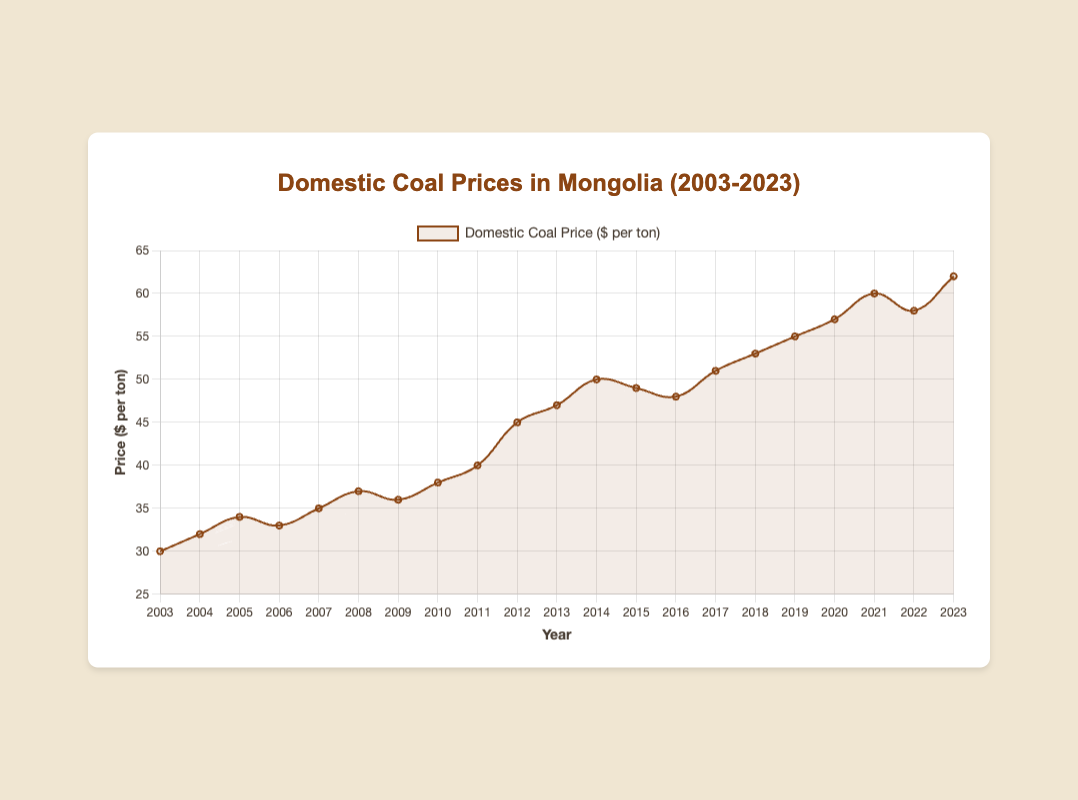What year did the domestic coal price first reach $50 per ton? To determine the first year the price hit $50 per ton, locate the point on the line where the y-axis value is $50. This occurs in 2014.
Answer: 2014 What is the highest domestic coal price recorded in the chart? Scan the line chart to find the peak value along the y-axis. The maximum price recorded is $62 per ton.
Answer: $62 per ton Which year saw the greatest year-over-year increase in coal prices? Calculate the year-over-year differences by subtracting the previous year's price from the current year's price and find the largest difference. The increase from $40 (2011) to $45 (2012) is $5.
Answer: 2012 Compare the coal prices in 2013 and 2023. Which year had a higher price, and by how much? Evaluate the coal prices for 2013 and 2023, which were $47 and $62 per ton respectively. Calculate the difference: $62 - $47 = $15.
Answer: 2023 had a higher price by $15 How many years did the coal price decrease compared to the previous year? Notice the downward slopes in the chart to identify decreases from one year to the next. The prices decreased in 2006, 2009, 2015, and 2022.
Answer: 4 years What was the average coal price over the last 5 years (2019-2023)? Sum the prices from 2019 to 2023: $55 + $57 + $60 + $58 + $62 = $292. Divide this by 5 to find the average: $292 / 5 = $58.4.
Answer: $58.4 In which year was the coal price closest to $38 per ton? Examine the chart to find the year where the price was closest to $38. In 2010, the price was $38 per ton.
Answer: 2010 What is the trend of coal prices from 2016 to 2018? Observe the line segments from 2016 to 2018. The prices increased from $48 (2016) to $53 (2018).
Answer: Upward trend 